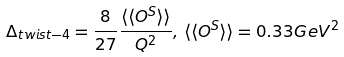<formula> <loc_0><loc_0><loc_500><loc_500>\Delta _ { t w i s t - 4 } = \frac { 8 } { 2 7 } \frac { \langle \langle O ^ { S } \rangle \rangle } { Q ^ { 2 } } , \, \langle \langle O ^ { S } \rangle \rangle = 0 . 3 3 G e V ^ { 2 }</formula> 